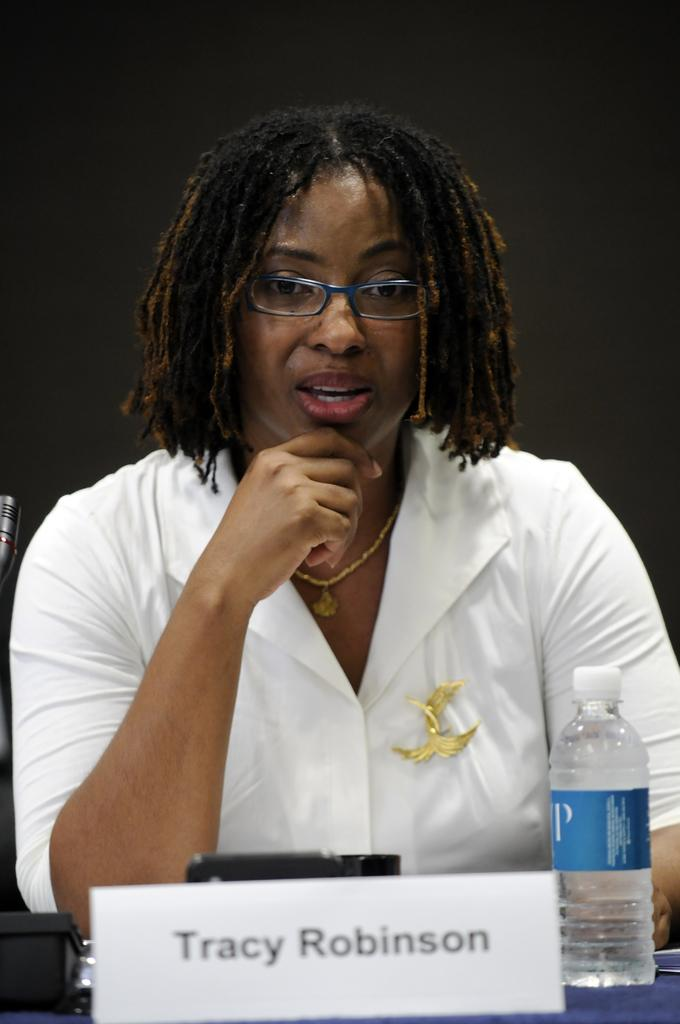Who is present in the image? There is a woman in the image. What can be seen on the woman's face? The woman is wearing spectacles. What is the woman wearing on her upper body? The woman is wearing a white shirt. What object is in front of the woman? There is a water bottle in front of the woman. What can be used to identify the woman in the image? There is a name plate in the image. What type of support does the woman provide to the van in the image? There is no van present in the image, so the woman cannot provide any support to a van. 